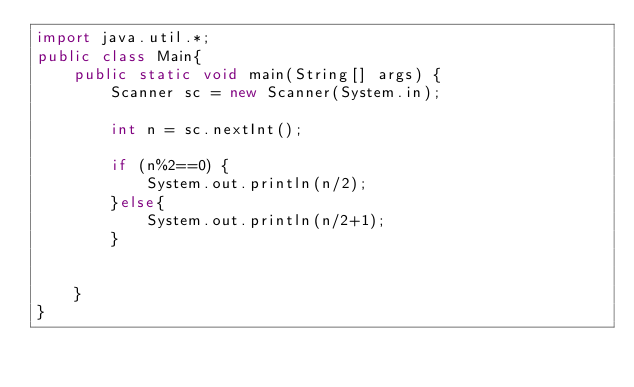Convert code to text. <code><loc_0><loc_0><loc_500><loc_500><_Java_>import java.util.*;
public class Main{
	public static void main(String[] args) {
		Scanner sc = new Scanner(System.in);

		int n = sc.nextInt();

		if (n%2==0) {
			System.out.println(n/2);
		}else{
			System.out.println(n/2+1);
		}


	}
}
</code> 